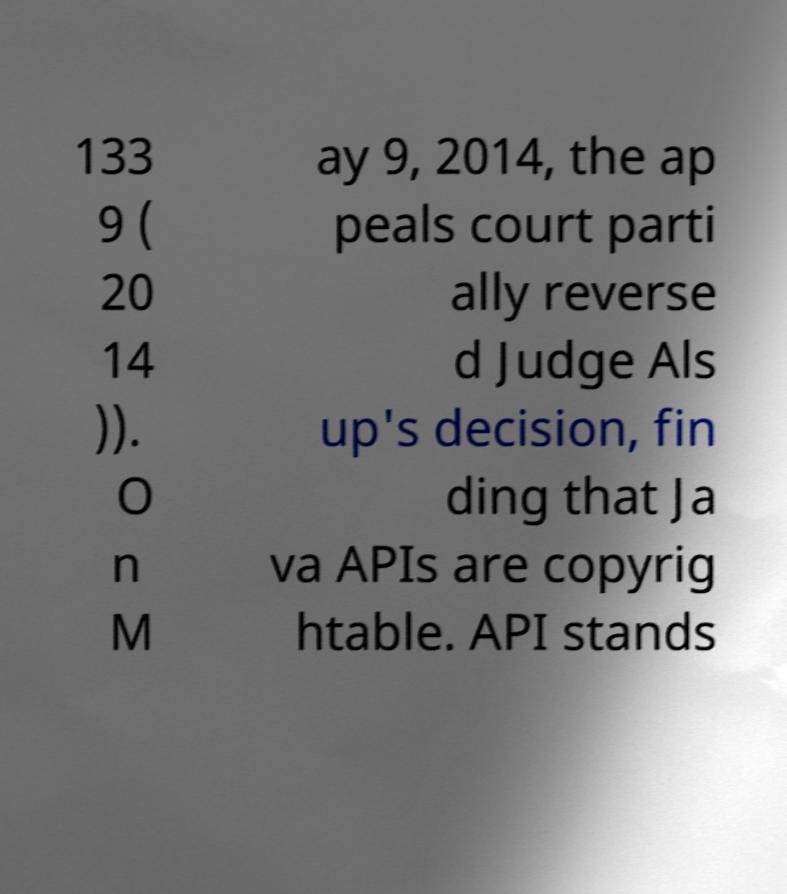Please read and relay the text visible in this image. What does it say? 133 9 ( 20 14 )). O n M ay 9, 2014, the ap peals court parti ally reverse d Judge Als up's decision, fin ding that Ja va APIs are copyrig htable. API stands 